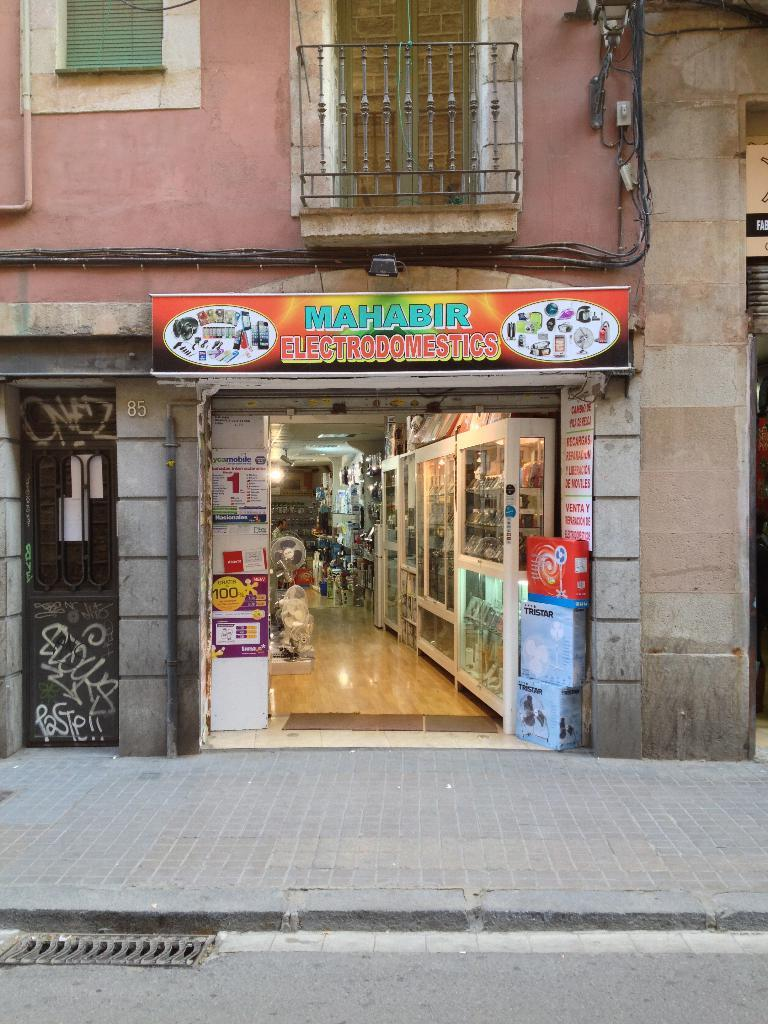<image>
Provide a brief description of the given image. the outside of a building that has a banner that says 'mahabir' 